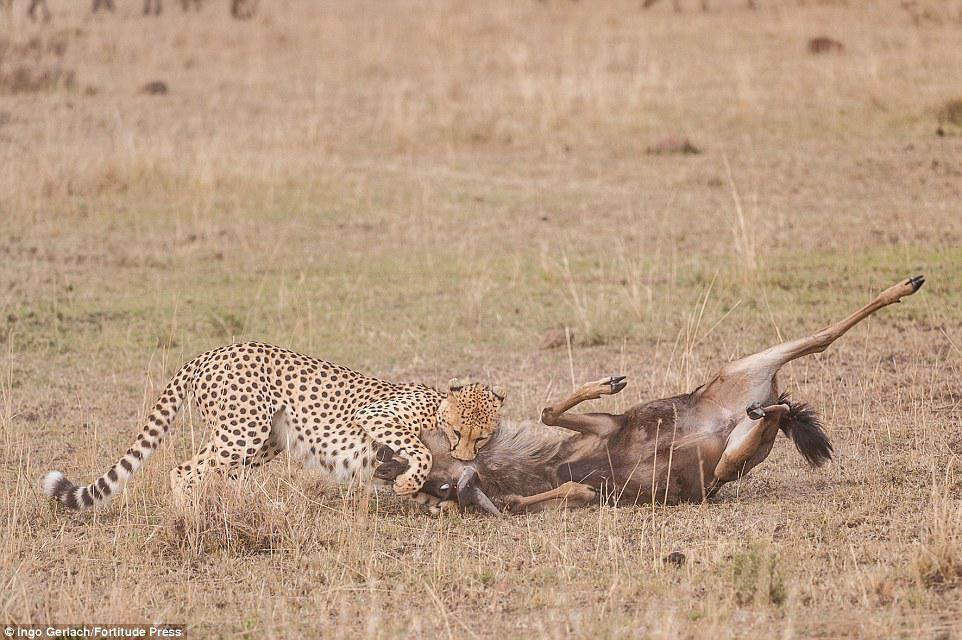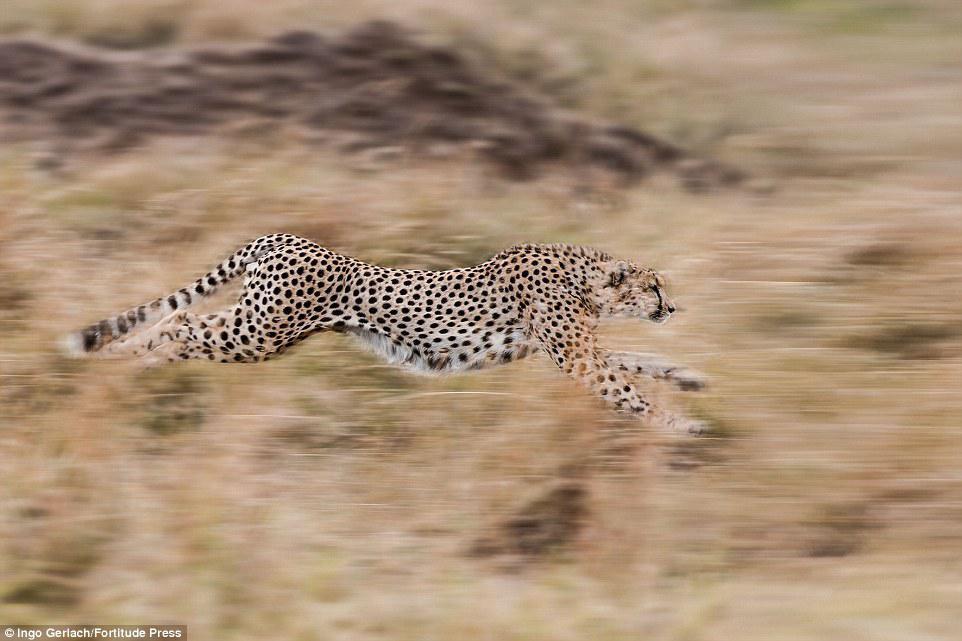The first image is the image on the left, the second image is the image on the right. Evaluate the accuracy of this statement regarding the images: "One or more cheetahs are catching another animal in one of the photos.". Is it true? Answer yes or no. Yes. The first image is the image on the left, the second image is the image on the right. Given the left and right images, does the statement "An image shows a spotted wild cat taking down its hooved prey." hold true? Answer yes or no. Yes. 